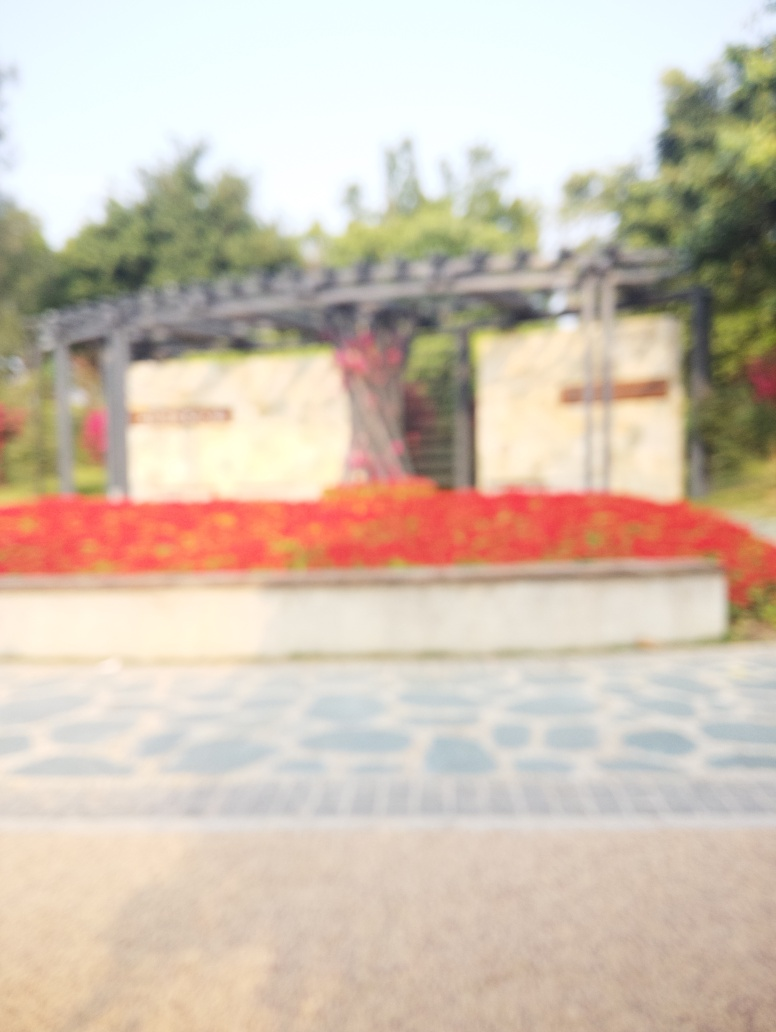What type of location is depicted in this image? While the specific details are unclear due to the blurriness of the image, it appears to be an outdoor setting, possibly a park or garden entrance, with red flowers in the background and a paved path leading up to it. 